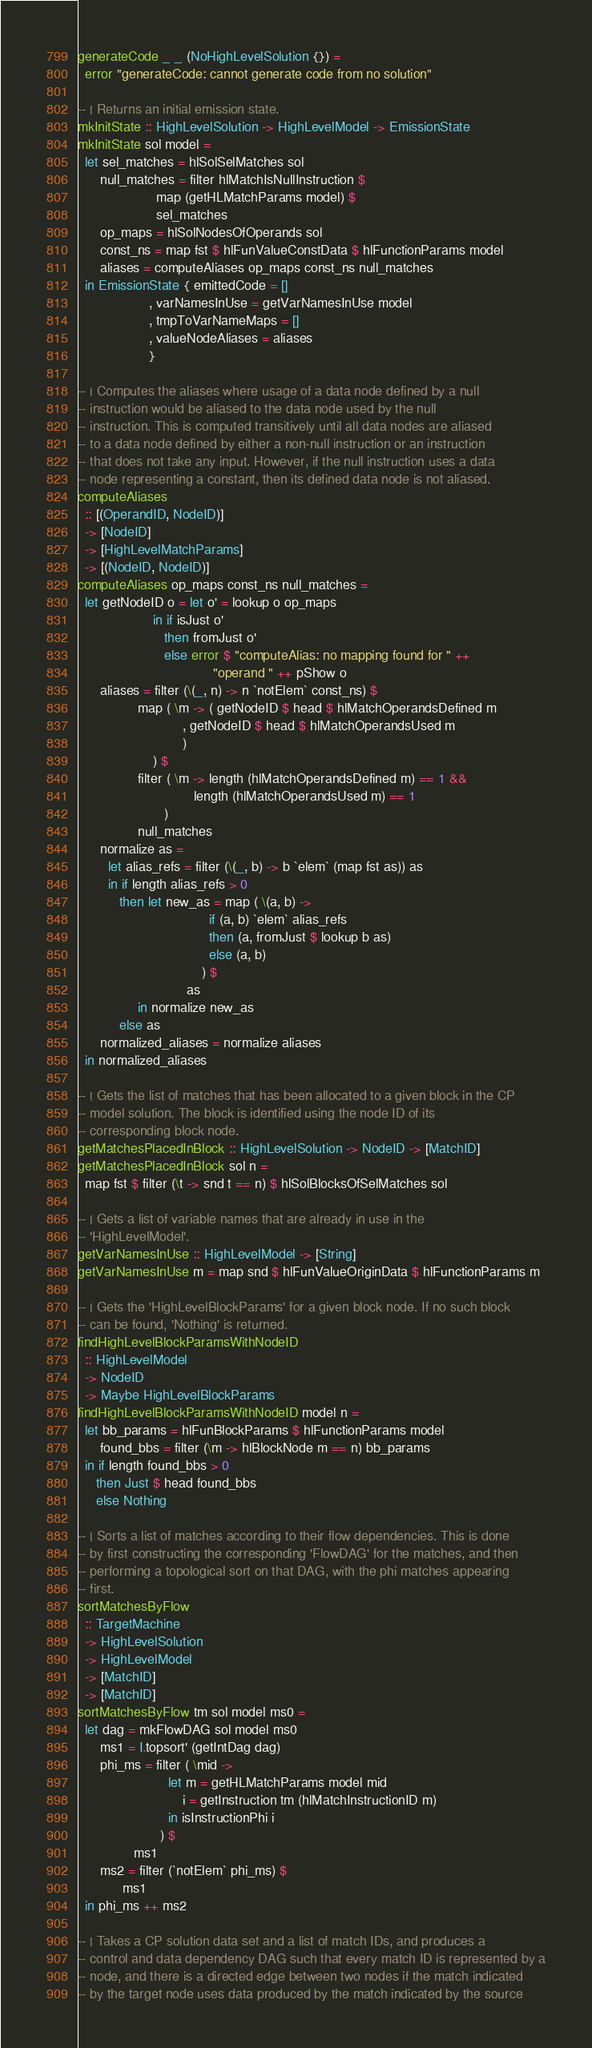Convert code to text. <code><loc_0><loc_0><loc_500><loc_500><_Haskell_>
generateCode _ _ (NoHighLevelSolution {}) =
  error "generateCode: cannot generate code from no solution"

-- | Returns an initial emission state.
mkInitState :: HighLevelSolution -> HighLevelModel -> EmissionState
mkInitState sol model =
  let sel_matches = hlSolSelMatches sol
      null_matches = filter hlMatchIsNullInstruction $
                     map (getHLMatchParams model) $
                     sel_matches
      op_maps = hlSolNodesOfOperands sol
      const_ns = map fst $ hlFunValueConstData $ hlFunctionParams model
      aliases = computeAliases op_maps const_ns null_matches
  in EmissionState { emittedCode = []
                   , varNamesInUse = getVarNamesInUse model
                   , tmpToVarNameMaps = []
                   , valueNodeAliases = aliases
                   }

-- | Computes the aliases where usage of a data node defined by a null
-- instruction would be aliased to the data node used by the null
-- instruction. This is computed transitively until all data nodes are aliased
-- to a data node defined by either a non-null instruction or an instruction
-- that does not take any input. However, if the null instruction uses a data
-- node representing a constant, then its defined data node is not aliased.
computeAliases
  :: [(OperandID, NodeID)]
  -> [NodeID]
  -> [HighLevelMatchParams]
  -> [(NodeID, NodeID)]
computeAliases op_maps const_ns null_matches =
  let getNodeID o = let o' = lookup o op_maps
                    in if isJust o'
                       then fromJust o'
                       else error $ "computeAlias: no mapping found for " ++
                                    "operand " ++ pShow o
      aliases = filter (\(_, n) -> n `notElem` const_ns) $
                map ( \m -> ( getNodeID $ head $ hlMatchOperandsDefined m
                            , getNodeID $ head $ hlMatchOperandsUsed m
                            )
                    ) $
                filter ( \m -> length (hlMatchOperandsDefined m) == 1 &&
                               length (hlMatchOperandsUsed m) == 1
                       )
                null_matches
      normalize as =
        let alias_refs = filter (\(_, b) -> b `elem` (map fst as)) as
        in if length alias_refs > 0
           then let new_as = map ( \(a, b) ->
                                   if (a, b) `elem` alias_refs
                                   then (a, fromJust $ lookup b as)
                                   else (a, b)
                                 ) $
                             as
                in normalize new_as
           else as
      normalized_aliases = normalize aliases
  in normalized_aliases

-- | Gets the list of matches that has been allocated to a given block in the CP
-- model solution. The block is identified using the node ID of its
-- corresponding block node.
getMatchesPlacedInBlock :: HighLevelSolution -> NodeID -> [MatchID]
getMatchesPlacedInBlock sol n =
  map fst $ filter (\t -> snd t == n) $ hlSolBlocksOfSelMatches sol

-- | Gets a list of variable names that are already in use in the
-- 'HighLevelModel'.
getVarNamesInUse :: HighLevelModel -> [String]
getVarNamesInUse m = map snd $ hlFunValueOriginData $ hlFunctionParams m

-- | Gets the 'HighLevelBlockParams' for a given block node. If no such block
-- can be found, 'Nothing' is returned.
findHighLevelBlockParamsWithNodeID
  :: HighLevelModel
  -> NodeID
  -> Maybe HighLevelBlockParams
findHighLevelBlockParamsWithNodeID model n =
  let bb_params = hlFunBlockParams $ hlFunctionParams model
      found_bbs = filter (\m -> hlBlockNode m == n) bb_params
  in if length found_bbs > 0
     then Just $ head found_bbs
     else Nothing

-- | Sorts a list of matches according to their flow dependencies. This is done
-- by first constructing the corresponding 'FlowDAG' for the matches, and then
-- performing a topological sort on that DAG, with the phi matches appearing
-- first.
sortMatchesByFlow
  :: TargetMachine
  -> HighLevelSolution
  -> HighLevelModel
  -> [MatchID]
  -> [MatchID]
sortMatchesByFlow tm sol model ms0 =
  let dag = mkFlowDAG sol model ms0
      ms1 = I.topsort' (getIntDag dag)
      phi_ms = filter ( \mid ->
                        let m = getHLMatchParams model mid
                            i = getInstruction tm (hlMatchInstructionID m)
                        in isInstructionPhi i
                      ) $
               ms1
      ms2 = filter (`notElem` phi_ms) $
            ms1
  in phi_ms ++ ms2

-- | Takes a CP solution data set and a list of match IDs, and produces a
-- control and data dependency DAG such that every match ID is represented by a
-- node, and there is a directed edge between two nodes if the match indicated
-- by the target node uses data produced by the match indicated by the source</code> 